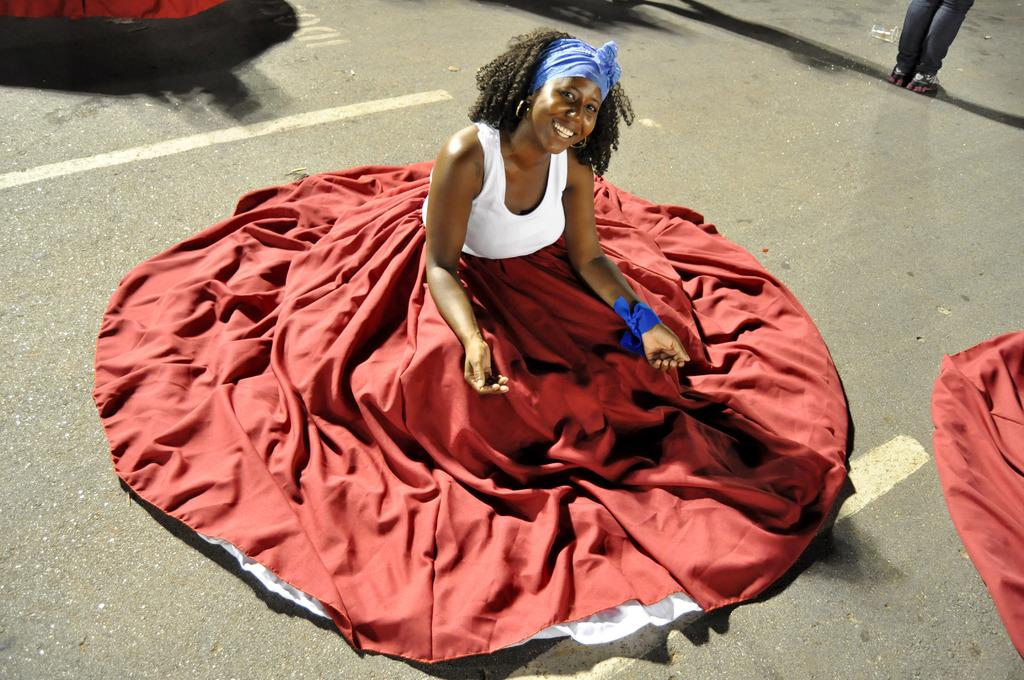What is the woman in the image doing? The woman is sitting and posing for a photo. Where is the woman located in the image? The woman is on the road. Are there any other people or objects in the image besides the woman? Yes, there are other objects in the image. Can you describe any part of a person other than the woman in the image? A person's legs are visible in the image. How many children are playing with a lock in the image? There are no children or locks present in the image. What is the value of the dime that is visible in the image? There is no dime present in the image. 